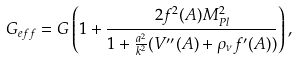Convert formula to latex. <formula><loc_0><loc_0><loc_500><loc_500>G _ { e f f } = G \left ( 1 + \frac { 2 f ^ { 2 } ( A ) M _ { P l } ^ { 2 } } { 1 + \frac { a ^ { 2 } } { k ^ { 2 } } ( V ^ { \prime \prime } ( A ) + \rho _ { \nu } f ^ { \prime } ( A ) ) } \right ) ,</formula> 